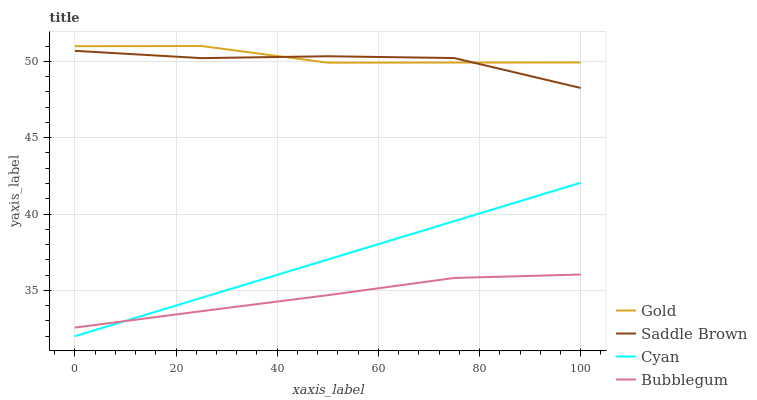Does Bubblegum have the minimum area under the curve?
Answer yes or no. Yes. Does Gold have the maximum area under the curve?
Answer yes or no. Yes. Does Saddle Brown have the minimum area under the curve?
Answer yes or no. No. Does Saddle Brown have the maximum area under the curve?
Answer yes or no. No. Is Cyan the smoothest?
Answer yes or no. Yes. Is Saddle Brown the roughest?
Answer yes or no. Yes. Is Bubblegum the smoothest?
Answer yes or no. No. Is Bubblegum the roughest?
Answer yes or no. No. Does Cyan have the lowest value?
Answer yes or no. Yes. Does Bubblegum have the lowest value?
Answer yes or no. No. Does Gold have the highest value?
Answer yes or no. Yes. Does Saddle Brown have the highest value?
Answer yes or no. No. Is Cyan less than Gold?
Answer yes or no. Yes. Is Gold greater than Cyan?
Answer yes or no. Yes. Does Cyan intersect Bubblegum?
Answer yes or no. Yes. Is Cyan less than Bubblegum?
Answer yes or no. No. Is Cyan greater than Bubblegum?
Answer yes or no. No. Does Cyan intersect Gold?
Answer yes or no. No. 